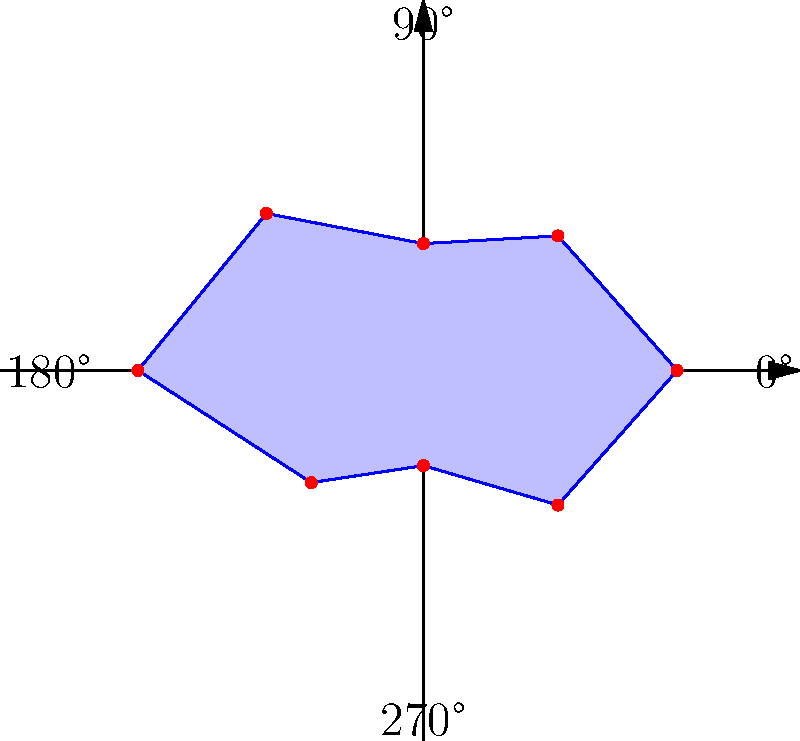The polar coordinate graph represents the vulnerability of a Rust-based cryptographic system to timing attacks at different angles. Each point on the graph indicates the severity of the vulnerability (distance from the center) at a specific angle. What is the sum of the two highest vulnerability values, and at which angles do they occur? To solve this problem, we need to follow these steps:

1. Identify all vulnerability values on the graph:
   - 0°: 8
   - 45°: 6
   - 90°: 4
   - 135°: 7
   - 180°: 9
   - 225°: 5
   - 270°: 3
   - 315°: 6

2. Find the two highest vulnerability values:
   - The highest value is 9 at 180°
   - The second highest value is 8 at 0°

3. Calculate the sum of these two values:
   $9 + 8 = 17$

4. Identify the angles at which these vulnerabilities occur:
   - 180° and 0°

Therefore, the sum of the two highest vulnerability values is 17, occurring at angles 180° and 0°.
Answer: 17; 180° and 0° 